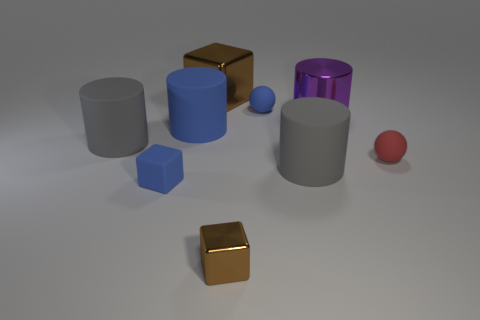What is the material of the blue object and how does it interact with light? The blue object, specifically the cylinder, appears to be made of a rubber-like material characterized by its matte finish. It interacts with light by diffusing it, which prevents the surface from reflecting sharp glares and instead provides a soft, evenly lit appearance. The texture and color of the blue rubber also seems to absorb some light, further accentuating its non-reflective quality. 